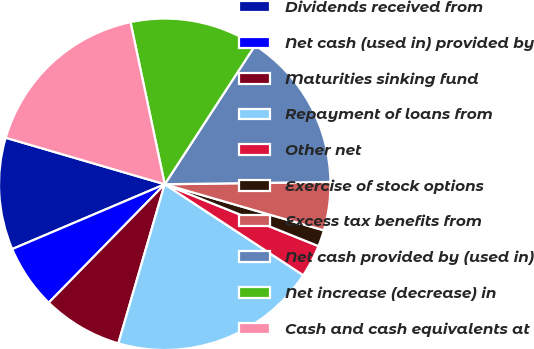Convert chart. <chart><loc_0><loc_0><loc_500><loc_500><pie_chart><fcel>Dividends received from<fcel>Net cash (used in) provided by<fcel>Maturities sinking fund<fcel>Repayment of loans from<fcel>Other net<fcel>Exercise of stock options<fcel>Excess tax benefits from<fcel>Net cash provided by (used in)<fcel>Net increase (decrease) in<fcel>Cash and cash equivalents at<nl><fcel>10.93%<fcel>6.27%<fcel>7.82%<fcel>20.27%<fcel>3.16%<fcel>1.6%<fcel>4.71%<fcel>15.6%<fcel>12.49%<fcel>17.16%<nl></chart> 